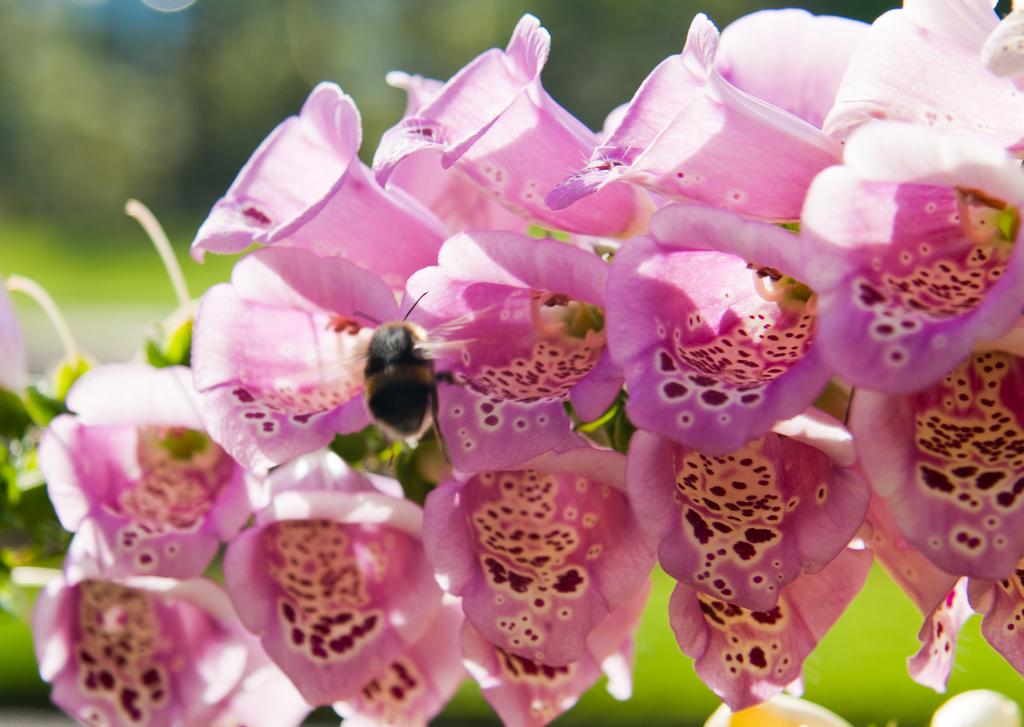What type of creature can be seen in the image? There is an insect in the image. What other objects or elements are present in the image? There are flowers in the image. Can you describe the background of the image? The background of the image is blurry. What type of cub can be seen playing with a pail in the image? There is no cub or pail present in the image; it features an insect and flowers. Is there a picture of a landscape in the background of the image? There is no picture or landscape mentioned in the provided facts; the background is simply described as blurry. 